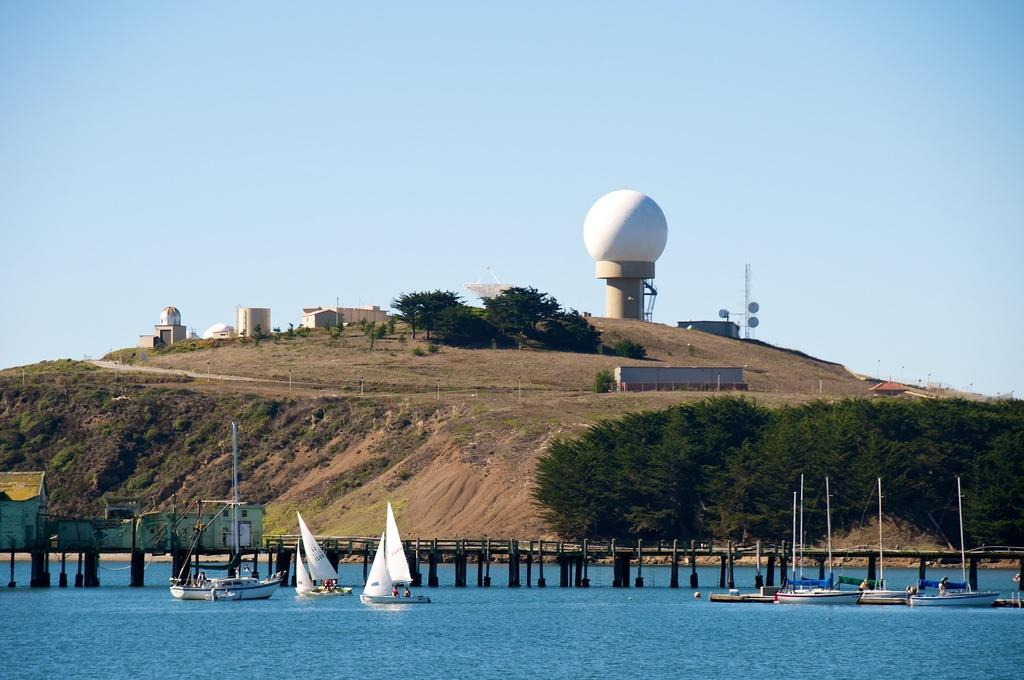What type of vehicles can be seen floating on the water in the image? There are sailboats floating on the water in the image. What type of structure can be seen crossing over the water in the image? There is a bridge visible in the image. What type of residential structures can be seen in the image? There are houses in the image. What type of vertical structure can be seen in the image? There is a pole in the image. What type of natural vegetation can be seen in the image? Trees are present in the image. What type of elevated landform can be seen in the image? There is a hill in the image. What type of tall structure can be seen in the image? There is a tower in the image. What type of man-made structures can be seen in the image? There are buildings in the image. What can be seen in the background of the image? The sky is visible in the background of the image. What type of bread can be seen floating on the water in the image? There is no bread present in the image; it features sailboats floating on the water. What type of flat surface can be seen holding the sailboats in the image? There is no flat surface holding the sailboats in the image; they are floating on the water. 